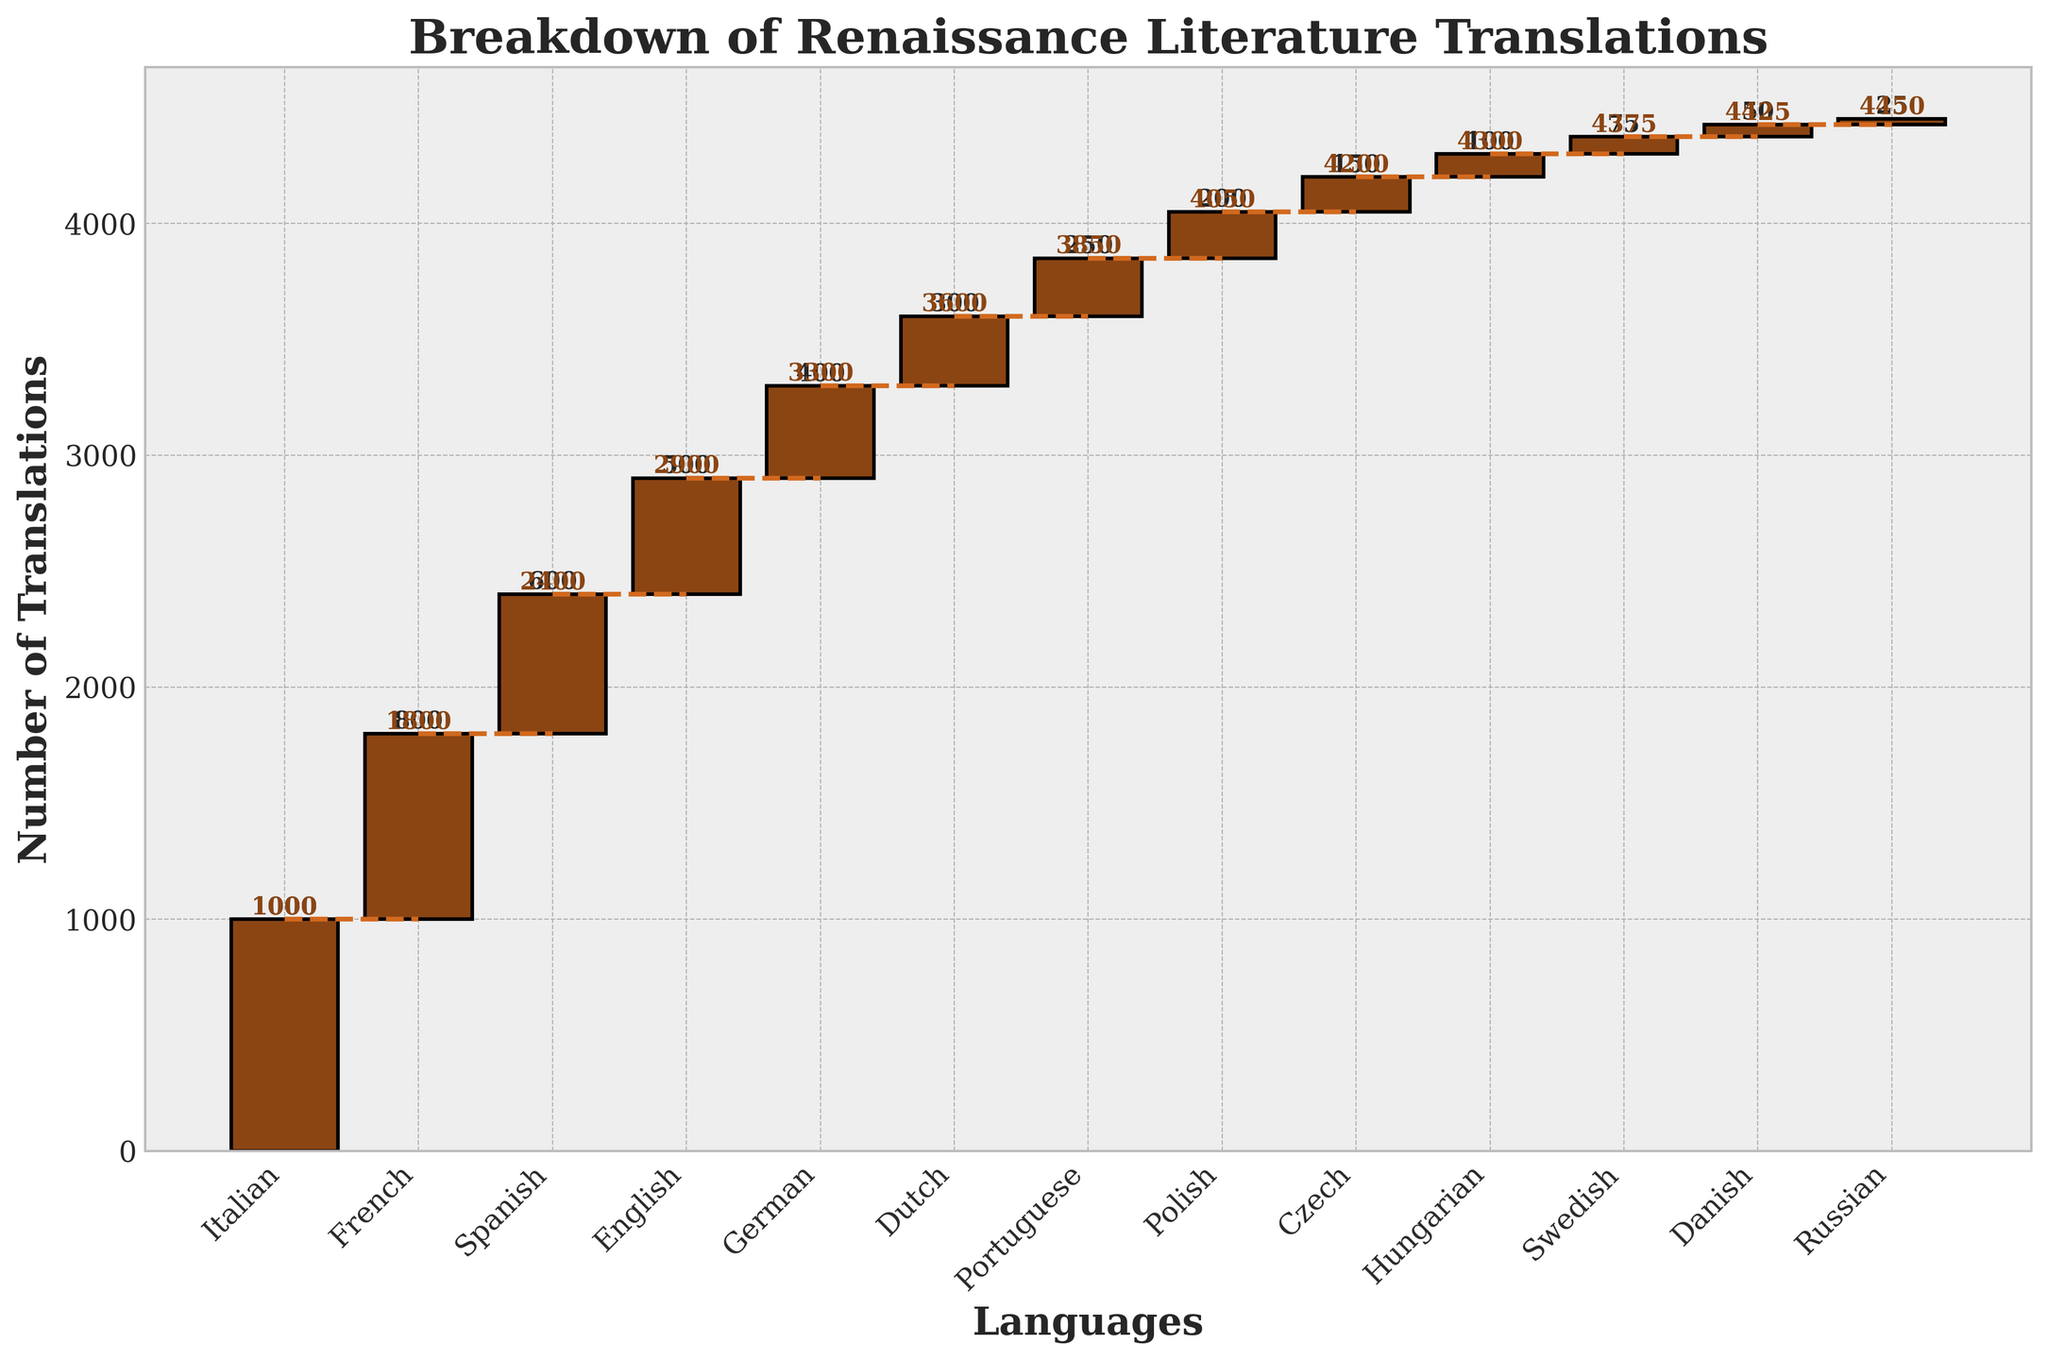What is the title of the chart? The title of the chart can be found at the top of the figure, and it reads "Breakdown of Renaissance Literature Translations".
Answer: Breakdown of Renaissance Literature Translations Which language has the highest number of translations? By examining the heights of the bars, the first bar, representing Italian, is the tallest, indicating that it has the highest number of translations.
Answer: Italian What is the cumulative number of translations for Spanish? Look for the Spanish bar and note the number at its top, which represents the cumulative translations. The cumulative number for Spanish is 2400.
Answer: 2400 How many more translations are there in French compared to English? To find the difference, look at the heights of the French and English bars. French has 800 translations, and English has 500. Subtracting 500 from 800 gives 300.
Answer: 300 Which language has fewer translations: Swedish or Dutch? Compare the heights of the bars for Swedish and Dutch. The Dutch bar is taller than the Swedish bar, indicating that Dutch has more translations. Thus, Swedish has fewer translations.
Answer: Swedish What is the overall cumulative number of translations displayed in the chart? Examine the topmost value of the final bar, corresponding to Russian, which is 4450, indicating the overall cumulative number of translations.
Answer: 4450 If the translations for English and German were combined, what would be their total? Add the individual translation numbers for English (500) and German (400) to find the combined total, which is 900.
Answer: 900 Which language shows an increase right after French? Refer to the chart and look at the bars immediately following the French bar. The Spanish bar is next, indicating that it follows French.
Answer: Spanish Which language has the least number of translations? Identify the shortest bar in the figure, which represents Russian, indicating it has the least number of translations.
Answer: Russian What's the average number of translations for Portuguese, Polish, and Czech? Add the number of translations for Portuguese (250), Polish (200), and Czech (150), then divide by 3 to get the average: (250 + 200 + 150) / 3 = 600 / 3 = 200.
Answer: 200 